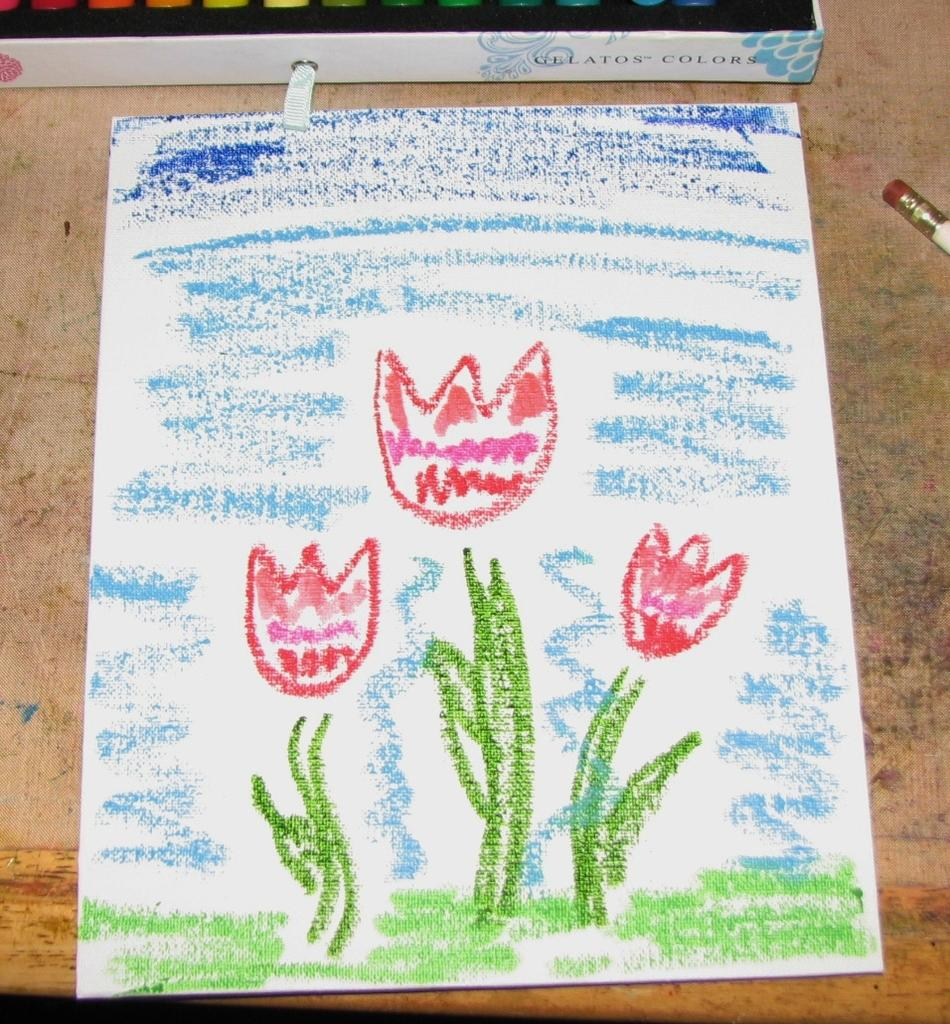What is depicted on the paper in the image? There is a drawing on the paper in the image. What tool was used to create the drawing? Crayons were used for the drawing. Where is the paper with the drawing located? The paper is on a table. What other writing or drawing tool is visible in the image? There is a pencil visible in the image. What container is present for the crayons? There is a crayons box in the image. What type of ant can be seen crawling on the ground in the image? There are no ants or ground visible in the image; it features a drawing on paper with crayons and a pencil. 